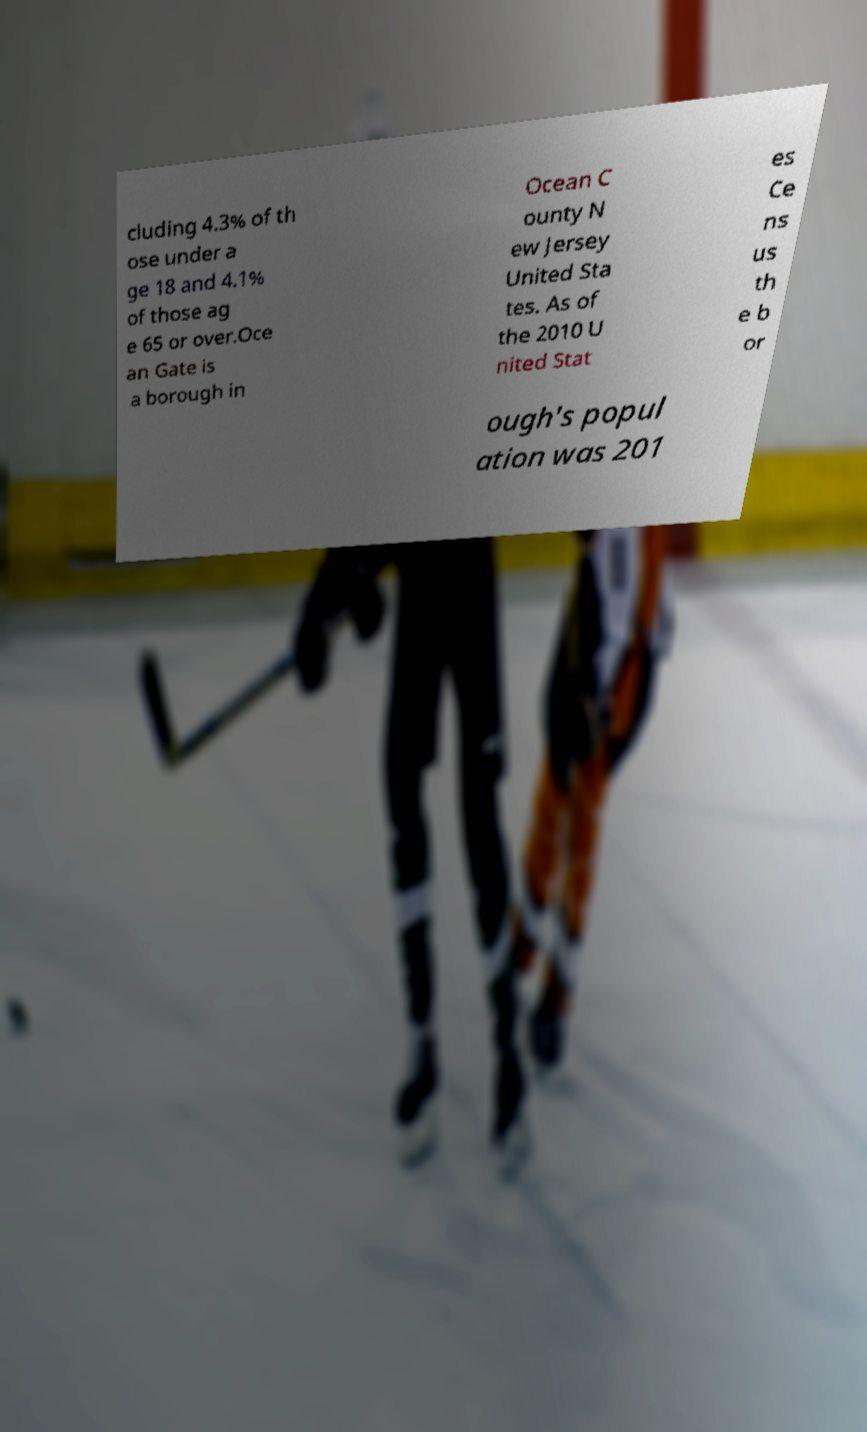Can you accurately transcribe the text from the provided image for me? cluding 4.3% of th ose under a ge 18 and 4.1% of those ag e 65 or over.Oce an Gate is a borough in Ocean C ounty N ew Jersey United Sta tes. As of the 2010 U nited Stat es Ce ns us th e b or ough's popul ation was 201 